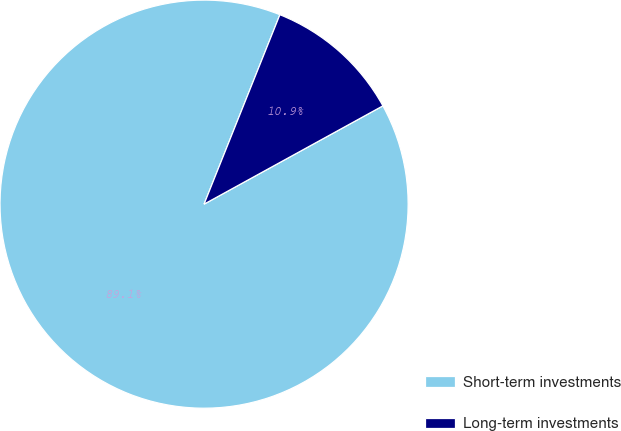Convert chart. <chart><loc_0><loc_0><loc_500><loc_500><pie_chart><fcel>Short-term investments<fcel>Long-term investments<nl><fcel>89.06%<fcel>10.94%<nl></chart> 